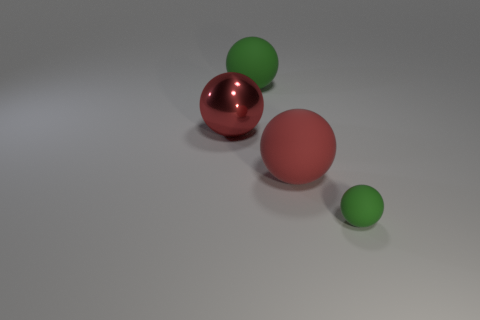Subtract 1 spheres. How many spheres are left? 3 Add 3 small green spheres. How many objects exist? 7 Subtract all cyan balls. Subtract all red blocks. How many balls are left? 4 Add 4 small green balls. How many small green balls exist? 5 Subtract 0 yellow balls. How many objects are left? 4 Subtract all tiny purple metallic objects. Subtract all red objects. How many objects are left? 2 Add 1 spheres. How many spheres are left? 5 